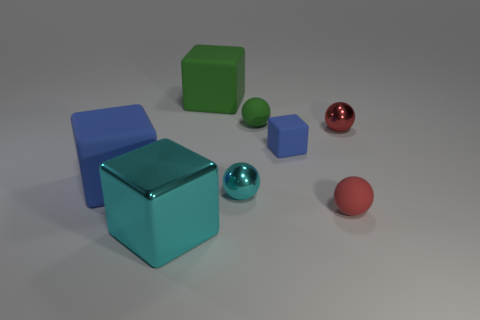Subtract 1 cubes. How many cubes are left? 3 Add 2 metal balls. How many objects exist? 10 Subtract all green spheres. Subtract all big objects. How many objects are left? 4 Add 8 tiny red rubber things. How many tiny red rubber things are left? 9 Add 2 red metallic spheres. How many red metallic spheres exist? 3 Subtract 1 red spheres. How many objects are left? 7 